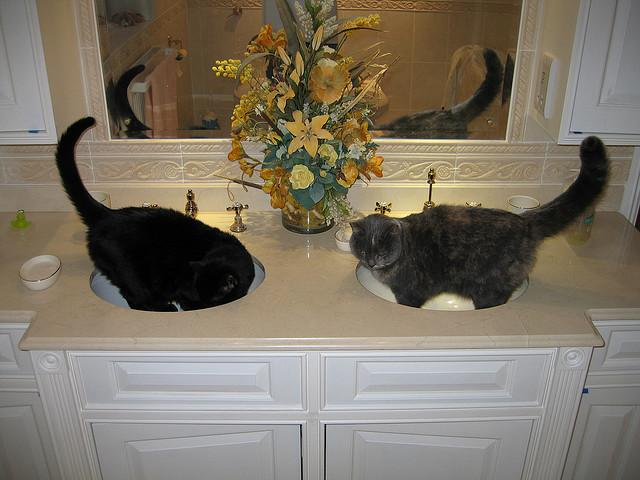Where are the cats playing? sinks 